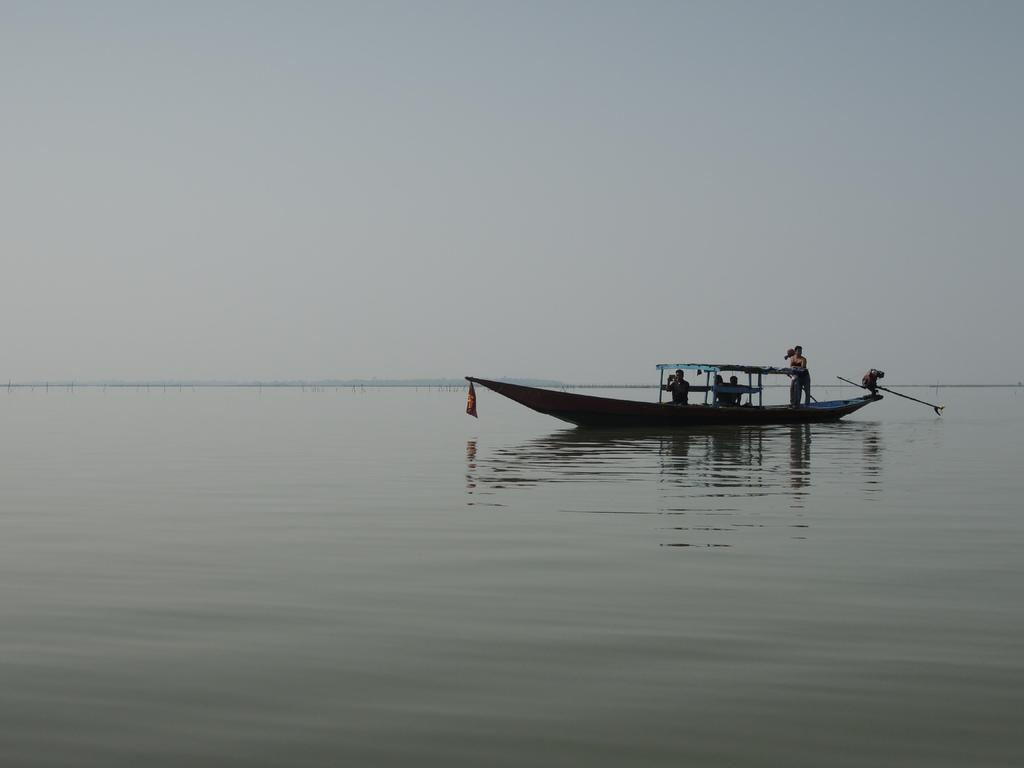What is the primary element in the image? There is water in the image. What are the people doing in the image? The people are on a boat in the image. What can be seen above the water in the image? The sky is visible in the image. What type of plantation can be seen in the image? There is no plantation present in the image; it features water, a boat, and the sky. 